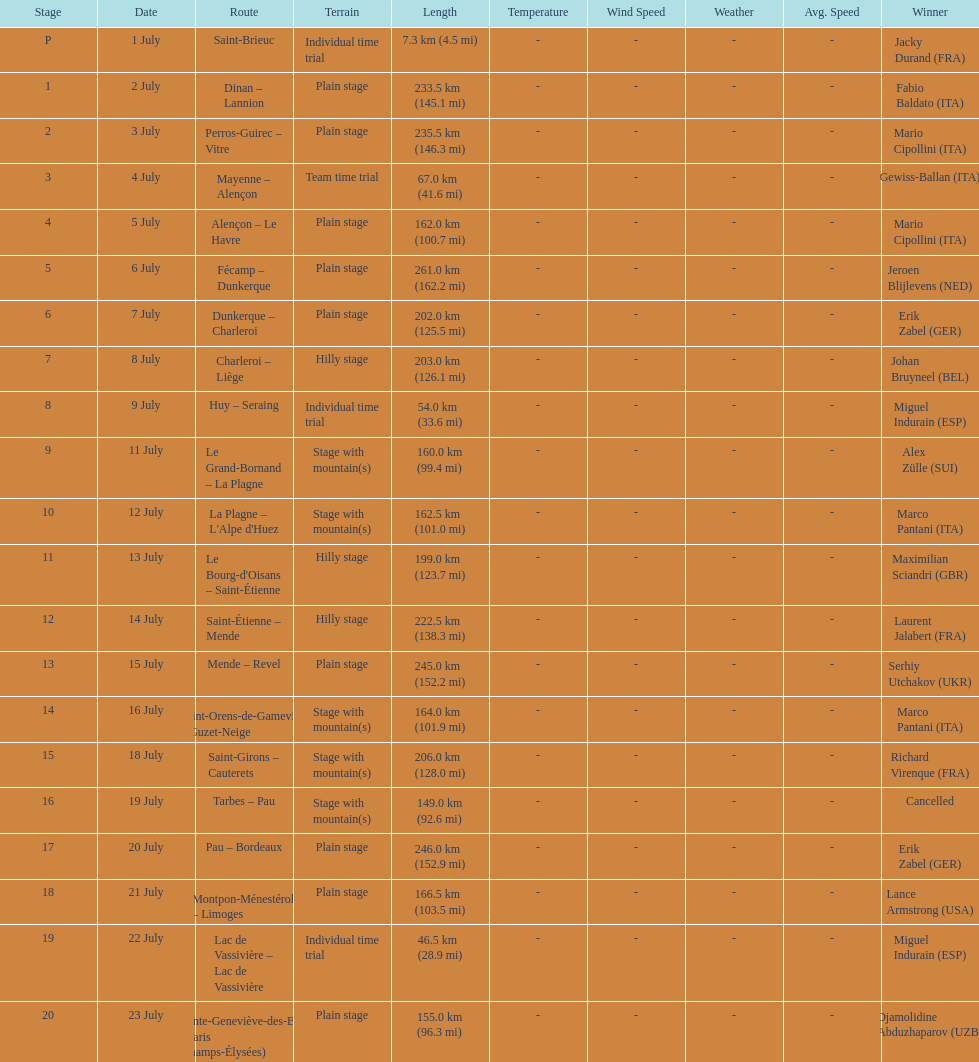How many stages were at least 200 km in length in the 1995 tour de france? 9. 